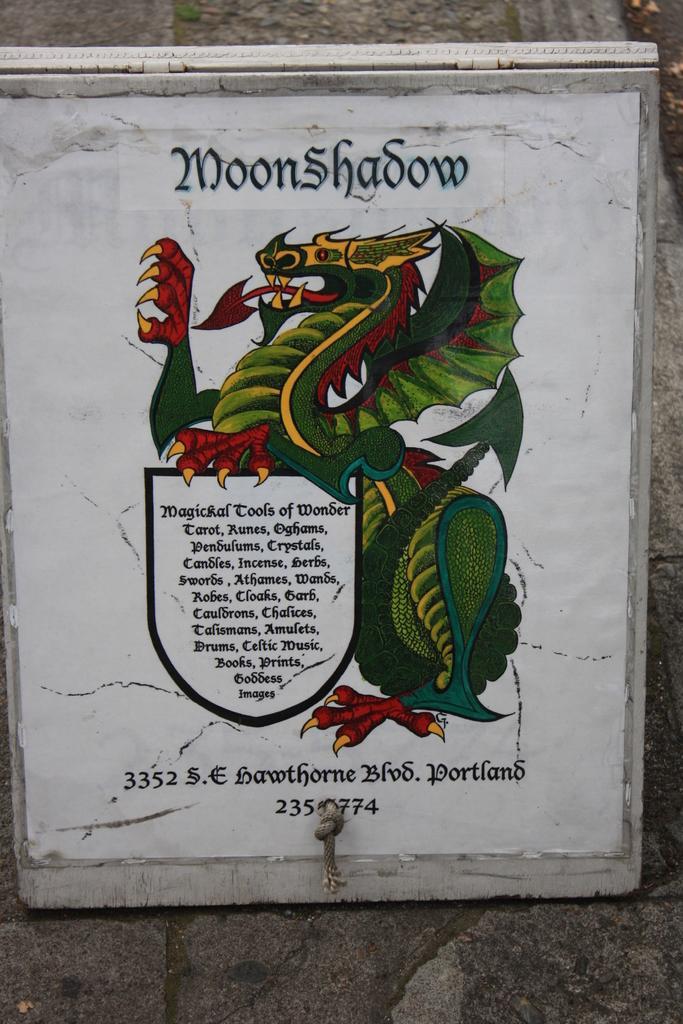Can you describe this image briefly? This image is taken outdoors. In the background there is a wall. In the middle of the image there is a text on it. 